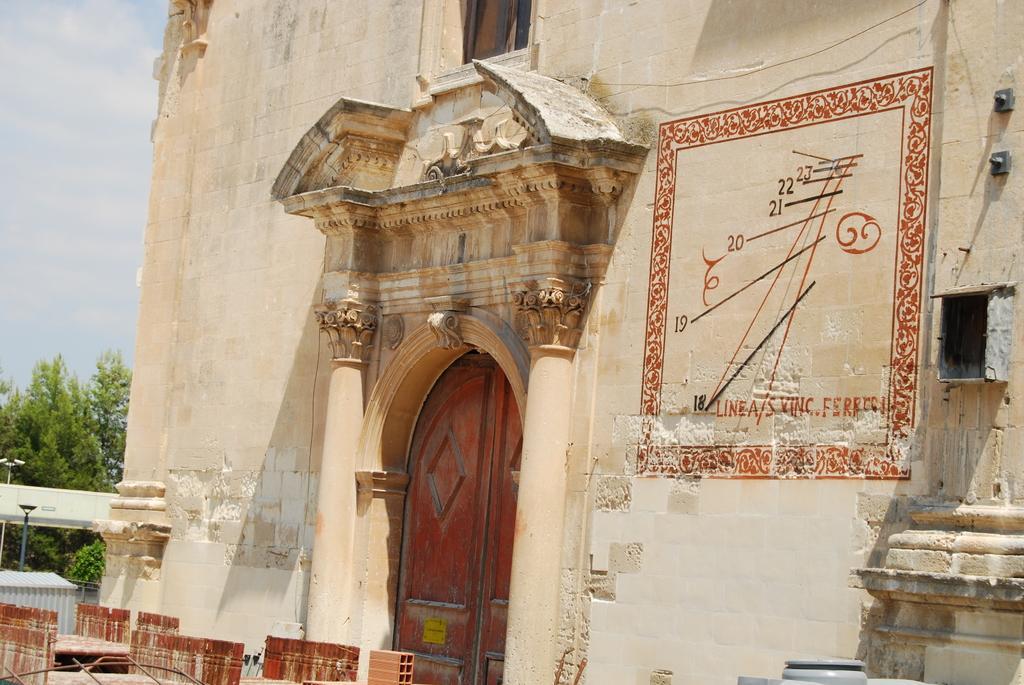In one or two sentences, can you explain what this image depicts? In this picture we can see a few brown objects on the left side. There is a door visible on a building. We can see a few numbers, text and signs on the wall. There are a few poles and trees visible on the left side. 